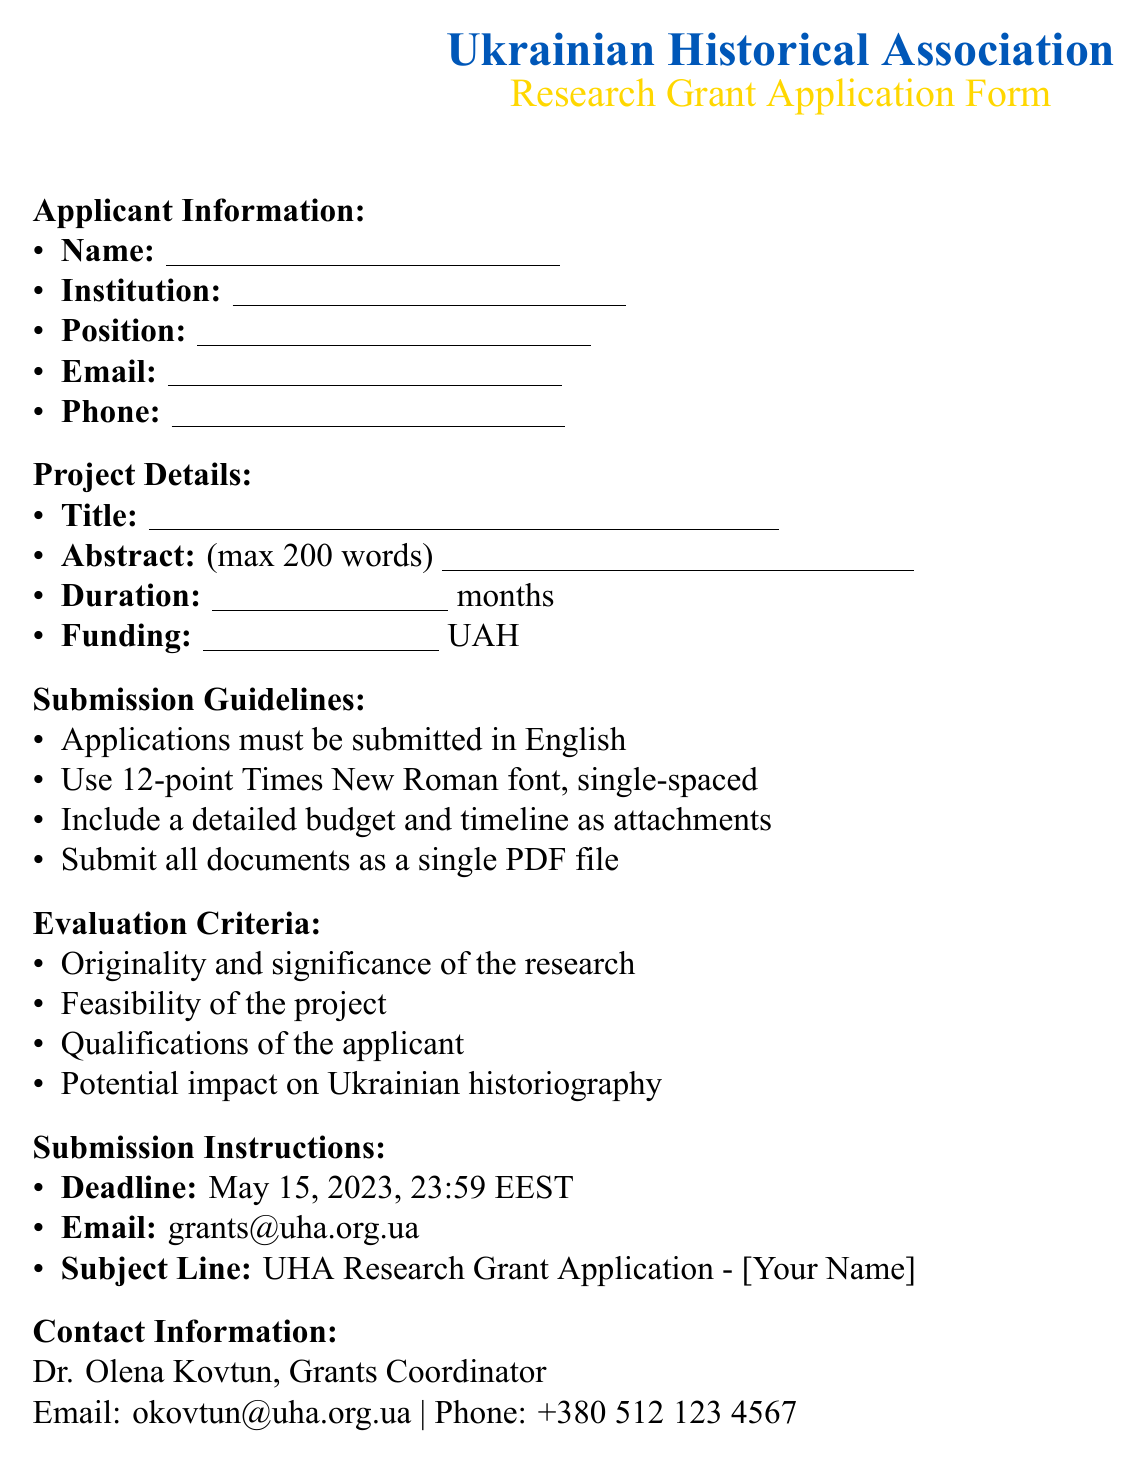What is the name of the association? The document begins with the title "Ukrainian Historical Association," indicating the name of the association.
Answer: Ukrainian Historical Association What is the submission deadline? The document specifies the deadline for submissions clearly mentioned under the Submission Instructions section.
Answer: May 15, 2023, 23:59 EEST What is the required font for the application? The Submission Guidelines section explicitly states the font requirements for the application submission.
Answer: Times New Roman Who is the Grants Coordinator? The document provides information on the contact person for inquiries, identified in the Contact Information section.
Answer: Dr. Olena Kovtun What is the maximum length for the abstract? The Project Details section specifies the word limit for the abstract of the application.
Answer: 200 words What email should applications be sent to? The Submission Instructions contain clear information regarding the appropriate email address for submissions.
Answer: grants@uha.org.ua What should be included as attachments? The Submission Guidelines section lists the necessary attachments required along with the application.
Answer: Detailed budget and timeline What criteria are used for evaluation? The Evaluation Criteria section outlines the factors that will be considered in assessing applications.
Answer: Originality and significance of the research, feasibility of the project, qualifications of the applicant, potential impact on Ukrainian historiography 